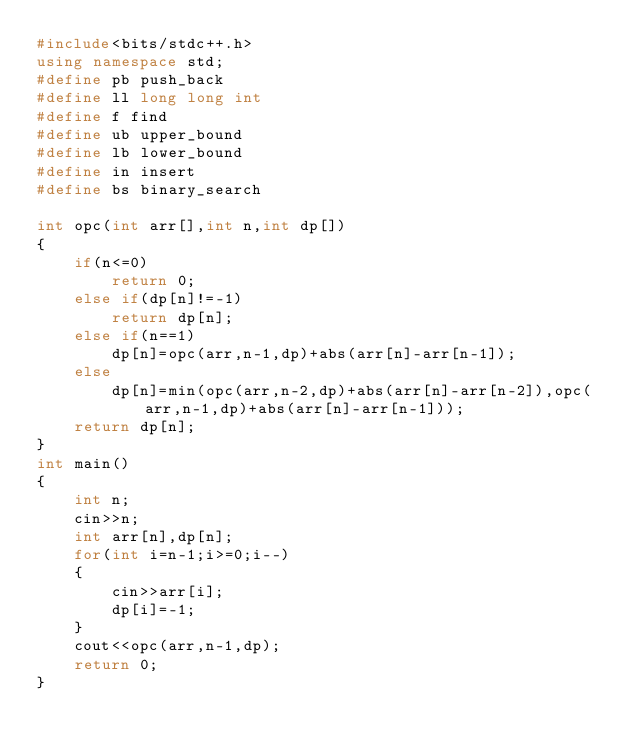<code> <loc_0><loc_0><loc_500><loc_500><_C++_>#include<bits/stdc++.h>
using namespace std;
#define pb push_back
#define ll long long int
#define f find
#define ub upper_bound
#define lb lower_bound
#define in insert
#define bs binary_search   

int opc(int arr[],int n,int dp[])
{
    if(n<=0)
        return 0;
    else if(dp[n]!=-1)
        return dp[n];
    else if(n==1)
        dp[n]=opc(arr,n-1,dp)+abs(arr[n]-arr[n-1]);
    else
        dp[n]=min(opc(arr,n-2,dp)+abs(arr[n]-arr[n-2]),opc(arr,n-1,dp)+abs(arr[n]-arr[n-1]));
    return dp[n];
}
int main()
{
    int n;
    cin>>n;
    int arr[n],dp[n];
    for(int i=n-1;i>=0;i--)
    {
        cin>>arr[i];
        dp[i]=-1;
    }
    cout<<opc(arr,n-1,dp);
    return 0;
}</code> 